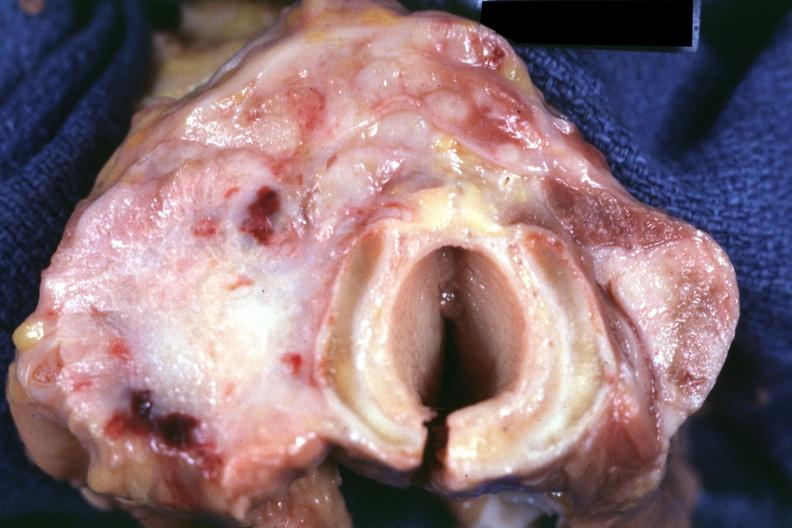what is present?
Answer the question using a single word or phrase. Endocrine 